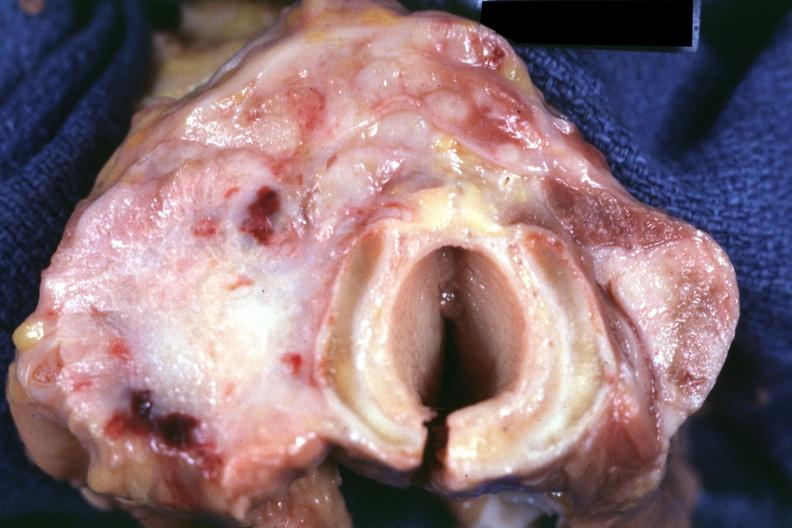what is present?
Answer the question using a single word or phrase. Endocrine 